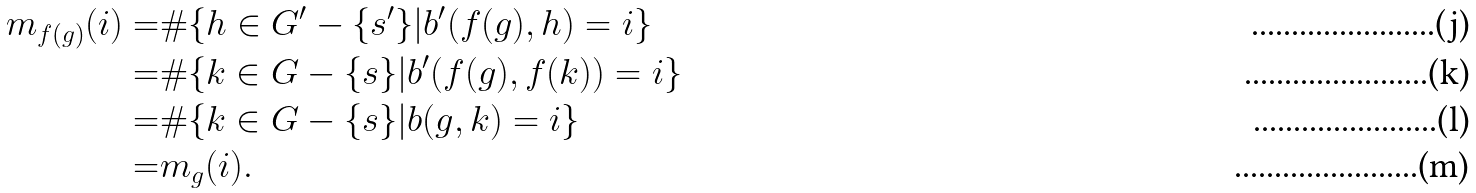<formula> <loc_0><loc_0><loc_500><loc_500>m _ { f ( g ) } ( i ) = & \# \{ h \in G ^ { \prime } - \{ s ^ { \prime } \} | b ^ { \prime } ( f ( g ) , h ) = i \} \\ = & \# \{ k \in G - \{ s \} | b ^ { \prime } ( f ( g ) , f ( k ) ) = i \} \\ = & \# \{ k \in G - \{ s \} | b ( g , k ) = i \} \\ = & m _ { g } ( i ) .</formula> 